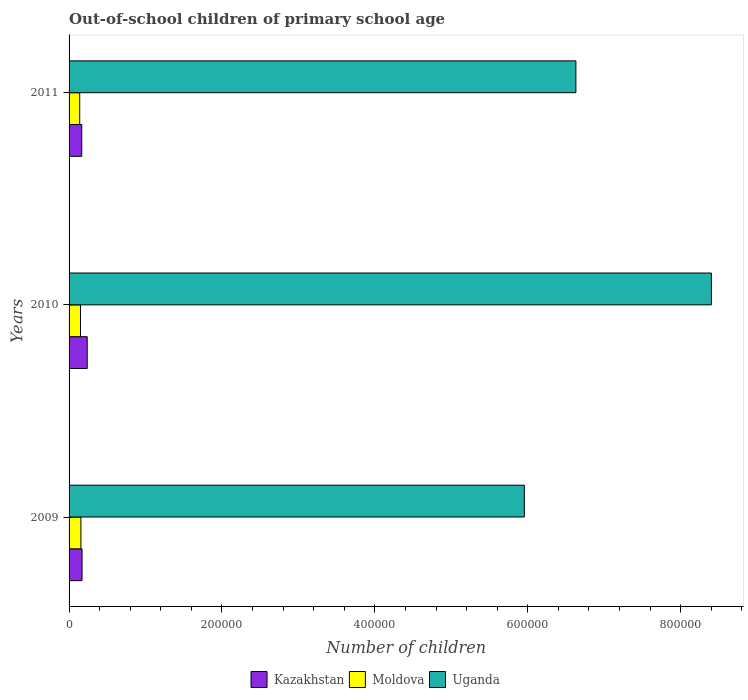How many bars are there on the 1st tick from the bottom?
Your answer should be compact. 3. In how many cases, is the number of bars for a given year not equal to the number of legend labels?
Your answer should be very brief. 0. What is the number of out-of-school children in Uganda in 2009?
Give a very brief answer. 5.96e+05. Across all years, what is the maximum number of out-of-school children in Moldova?
Provide a short and direct response. 1.55e+04. Across all years, what is the minimum number of out-of-school children in Moldova?
Keep it short and to the point. 1.39e+04. What is the total number of out-of-school children in Uganda in the graph?
Make the answer very short. 2.10e+06. What is the difference between the number of out-of-school children in Kazakhstan in 2009 and that in 2010?
Your answer should be compact. -6757. What is the difference between the number of out-of-school children in Kazakhstan in 2010 and the number of out-of-school children in Uganda in 2011?
Give a very brief answer. -6.39e+05. What is the average number of out-of-school children in Uganda per year?
Your answer should be very brief. 7.00e+05. In the year 2009, what is the difference between the number of out-of-school children in Kazakhstan and number of out-of-school children in Moldova?
Your answer should be very brief. 1481. In how many years, is the number of out-of-school children in Moldova greater than 520000 ?
Provide a succinct answer. 0. What is the ratio of the number of out-of-school children in Uganda in 2009 to that in 2011?
Make the answer very short. 0.9. Is the difference between the number of out-of-school children in Kazakhstan in 2009 and 2011 greater than the difference between the number of out-of-school children in Moldova in 2009 and 2011?
Your response must be concise. No. What is the difference between the highest and the second highest number of out-of-school children in Uganda?
Make the answer very short. 1.77e+05. What is the difference between the highest and the lowest number of out-of-school children in Uganda?
Keep it short and to the point. 2.45e+05. What does the 2nd bar from the top in 2010 represents?
Keep it short and to the point. Moldova. What does the 2nd bar from the bottom in 2009 represents?
Ensure brevity in your answer.  Moldova. How many bars are there?
Your answer should be very brief. 9. Are all the bars in the graph horizontal?
Provide a succinct answer. Yes. Does the graph contain grids?
Offer a terse response. No. How are the legend labels stacked?
Your response must be concise. Horizontal. What is the title of the graph?
Offer a very short reply. Out-of-school children of primary school age. What is the label or title of the X-axis?
Your response must be concise. Number of children. What is the Number of children of Kazakhstan in 2009?
Offer a terse response. 1.70e+04. What is the Number of children of Moldova in 2009?
Offer a very short reply. 1.55e+04. What is the Number of children in Uganda in 2009?
Your answer should be very brief. 5.96e+05. What is the Number of children of Kazakhstan in 2010?
Offer a very short reply. 2.37e+04. What is the Number of children in Moldova in 2010?
Your answer should be very brief. 1.49e+04. What is the Number of children in Uganda in 2010?
Give a very brief answer. 8.40e+05. What is the Number of children in Kazakhstan in 2011?
Your answer should be very brief. 1.66e+04. What is the Number of children of Moldova in 2011?
Ensure brevity in your answer.  1.39e+04. What is the Number of children of Uganda in 2011?
Give a very brief answer. 6.63e+05. Across all years, what is the maximum Number of children of Kazakhstan?
Give a very brief answer. 2.37e+04. Across all years, what is the maximum Number of children of Moldova?
Offer a terse response. 1.55e+04. Across all years, what is the maximum Number of children in Uganda?
Provide a succinct answer. 8.40e+05. Across all years, what is the minimum Number of children of Kazakhstan?
Offer a very short reply. 1.66e+04. Across all years, what is the minimum Number of children of Moldova?
Your answer should be very brief. 1.39e+04. Across all years, what is the minimum Number of children in Uganda?
Provide a short and direct response. 5.96e+05. What is the total Number of children in Kazakhstan in the graph?
Offer a terse response. 5.72e+04. What is the total Number of children in Moldova in the graph?
Your answer should be compact. 4.44e+04. What is the total Number of children in Uganda in the graph?
Provide a succinct answer. 2.10e+06. What is the difference between the Number of children of Kazakhstan in 2009 and that in 2010?
Provide a succinct answer. -6757. What is the difference between the Number of children of Moldova in 2009 and that in 2010?
Keep it short and to the point. 546. What is the difference between the Number of children in Uganda in 2009 and that in 2010?
Provide a short and direct response. -2.45e+05. What is the difference between the Number of children of Kazakhstan in 2009 and that in 2011?
Provide a succinct answer. 399. What is the difference between the Number of children in Moldova in 2009 and that in 2011?
Make the answer very short. 1547. What is the difference between the Number of children in Uganda in 2009 and that in 2011?
Ensure brevity in your answer.  -6.74e+04. What is the difference between the Number of children of Kazakhstan in 2010 and that in 2011?
Give a very brief answer. 7156. What is the difference between the Number of children of Moldova in 2010 and that in 2011?
Offer a terse response. 1001. What is the difference between the Number of children of Uganda in 2010 and that in 2011?
Offer a very short reply. 1.77e+05. What is the difference between the Number of children in Kazakhstan in 2009 and the Number of children in Moldova in 2010?
Offer a very short reply. 2027. What is the difference between the Number of children in Kazakhstan in 2009 and the Number of children in Uganda in 2010?
Offer a terse response. -8.23e+05. What is the difference between the Number of children of Moldova in 2009 and the Number of children of Uganda in 2010?
Your answer should be compact. -8.25e+05. What is the difference between the Number of children in Kazakhstan in 2009 and the Number of children in Moldova in 2011?
Ensure brevity in your answer.  3028. What is the difference between the Number of children in Kazakhstan in 2009 and the Number of children in Uganda in 2011?
Make the answer very short. -6.46e+05. What is the difference between the Number of children in Moldova in 2009 and the Number of children in Uganda in 2011?
Provide a short and direct response. -6.47e+05. What is the difference between the Number of children in Kazakhstan in 2010 and the Number of children in Moldova in 2011?
Your response must be concise. 9785. What is the difference between the Number of children of Kazakhstan in 2010 and the Number of children of Uganda in 2011?
Give a very brief answer. -6.39e+05. What is the difference between the Number of children of Moldova in 2010 and the Number of children of Uganda in 2011?
Your answer should be compact. -6.48e+05. What is the average Number of children of Kazakhstan per year?
Make the answer very short. 1.91e+04. What is the average Number of children of Moldova per year?
Offer a terse response. 1.48e+04. What is the average Number of children in Uganda per year?
Offer a terse response. 7.00e+05. In the year 2009, what is the difference between the Number of children in Kazakhstan and Number of children in Moldova?
Keep it short and to the point. 1481. In the year 2009, what is the difference between the Number of children of Kazakhstan and Number of children of Uganda?
Give a very brief answer. -5.79e+05. In the year 2009, what is the difference between the Number of children of Moldova and Number of children of Uganda?
Give a very brief answer. -5.80e+05. In the year 2010, what is the difference between the Number of children in Kazakhstan and Number of children in Moldova?
Offer a very short reply. 8784. In the year 2010, what is the difference between the Number of children in Kazakhstan and Number of children in Uganda?
Provide a succinct answer. -8.16e+05. In the year 2010, what is the difference between the Number of children of Moldova and Number of children of Uganda?
Offer a very short reply. -8.25e+05. In the year 2011, what is the difference between the Number of children of Kazakhstan and Number of children of Moldova?
Keep it short and to the point. 2629. In the year 2011, what is the difference between the Number of children in Kazakhstan and Number of children in Uganda?
Make the answer very short. -6.46e+05. In the year 2011, what is the difference between the Number of children in Moldova and Number of children in Uganda?
Your answer should be very brief. -6.49e+05. What is the ratio of the Number of children of Kazakhstan in 2009 to that in 2010?
Ensure brevity in your answer.  0.72. What is the ratio of the Number of children in Moldova in 2009 to that in 2010?
Your answer should be very brief. 1.04. What is the ratio of the Number of children of Uganda in 2009 to that in 2010?
Offer a terse response. 0.71. What is the ratio of the Number of children in Kazakhstan in 2009 to that in 2011?
Offer a very short reply. 1.02. What is the ratio of the Number of children of Moldova in 2009 to that in 2011?
Offer a terse response. 1.11. What is the ratio of the Number of children of Uganda in 2009 to that in 2011?
Ensure brevity in your answer.  0.9. What is the ratio of the Number of children of Kazakhstan in 2010 to that in 2011?
Make the answer very short. 1.43. What is the ratio of the Number of children of Moldova in 2010 to that in 2011?
Offer a terse response. 1.07. What is the ratio of the Number of children in Uganda in 2010 to that in 2011?
Your answer should be compact. 1.27. What is the difference between the highest and the second highest Number of children of Kazakhstan?
Your answer should be compact. 6757. What is the difference between the highest and the second highest Number of children in Moldova?
Ensure brevity in your answer.  546. What is the difference between the highest and the second highest Number of children of Uganda?
Your answer should be very brief. 1.77e+05. What is the difference between the highest and the lowest Number of children of Kazakhstan?
Provide a succinct answer. 7156. What is the difference between the highest and the lowest Number of children in Moldova?
Give a very brief answer. 1547. What is the difference between the highest and the lowest Number of children of Uganda?
Provide a short and direct response. 2.45e+05. 